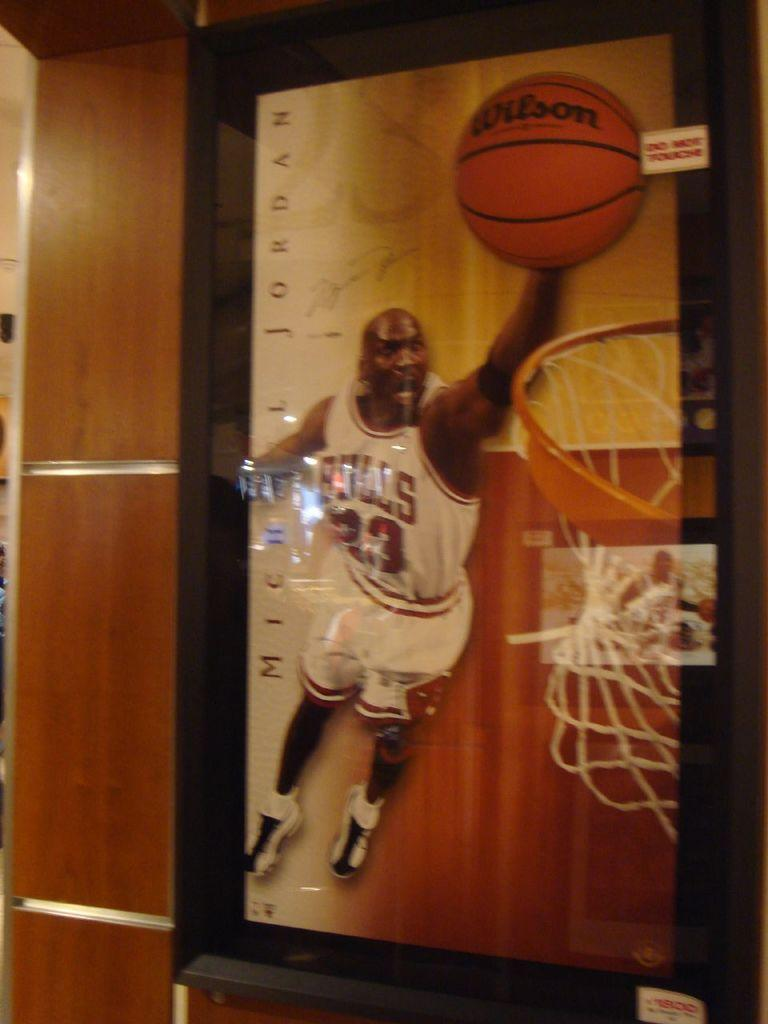<image>
Create a compact narrative representing the image presented. A picture of Michael Jordan wearing his Bulls 23 jersey 